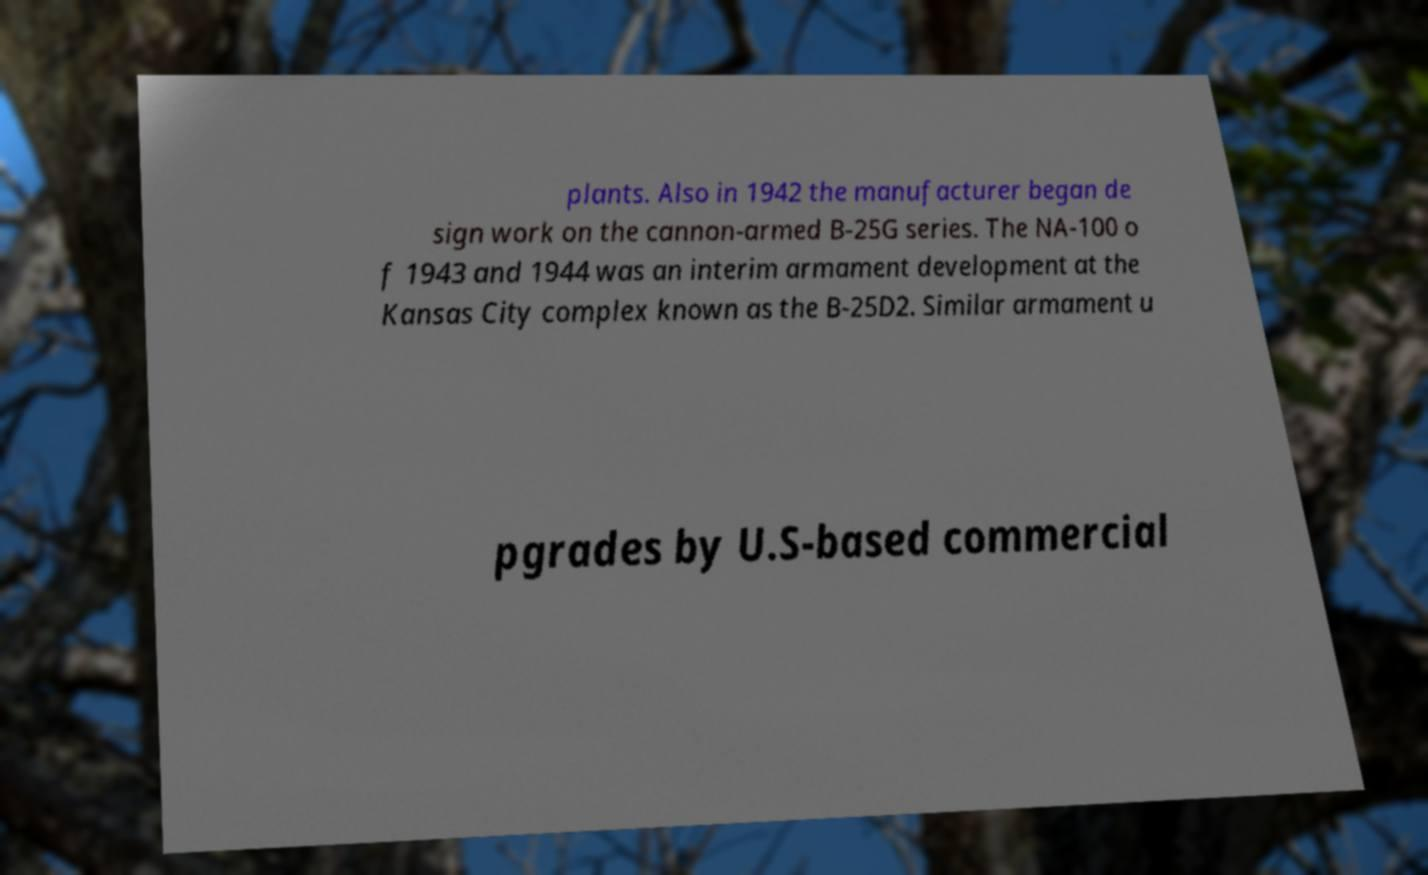Can you accurately transcribe the text from the provided image for me? plants. Also in 1942 the manufacturer began de sign work on the cannon-armed B-25G series. The NA-100 o f 1943 and 1944 was an interim armament development at the Kansas City complex known as the B-25D2. Similar armament u pgrades by U.S-based commercial 